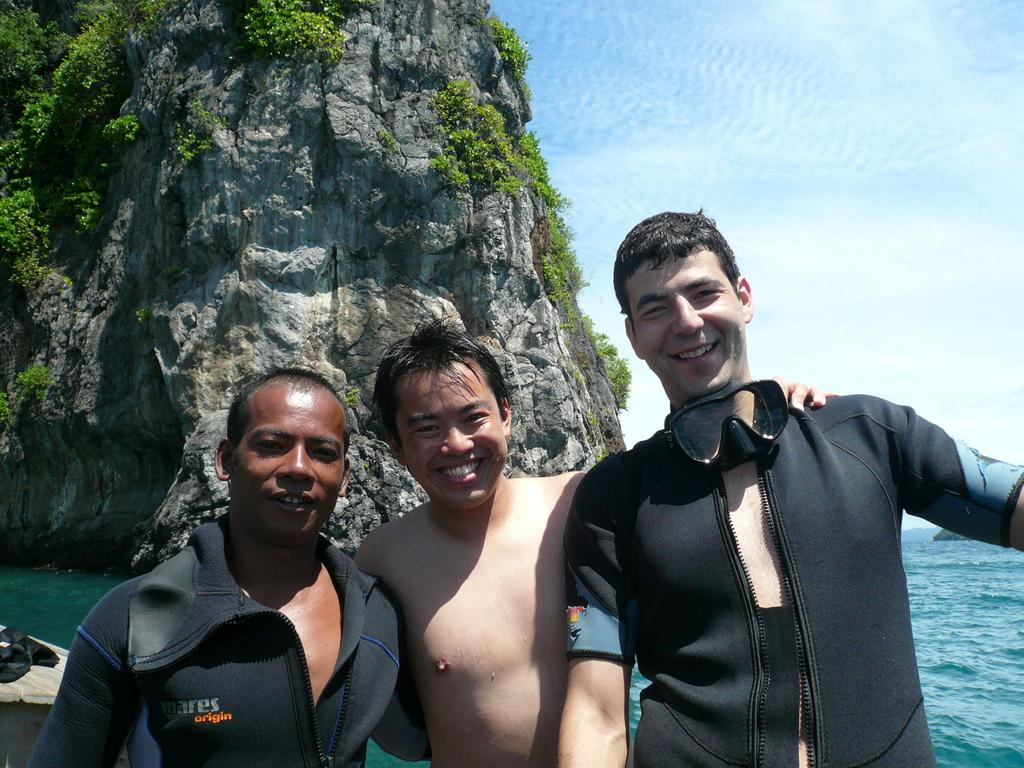How many people are in the image? There are three persons in the image. Where are the persons located? The persons are in the sea. What other object can be seen in the image besides the people? There is a big rock in the image. Are there any plants on the rock? Yes, the rock has small plants on it. What is visible in the background of the image? The sky is visible in the image. Can you see the partner of the person in the image? There is no mention of a partner in the image, so it cannot be determined if one is present. 